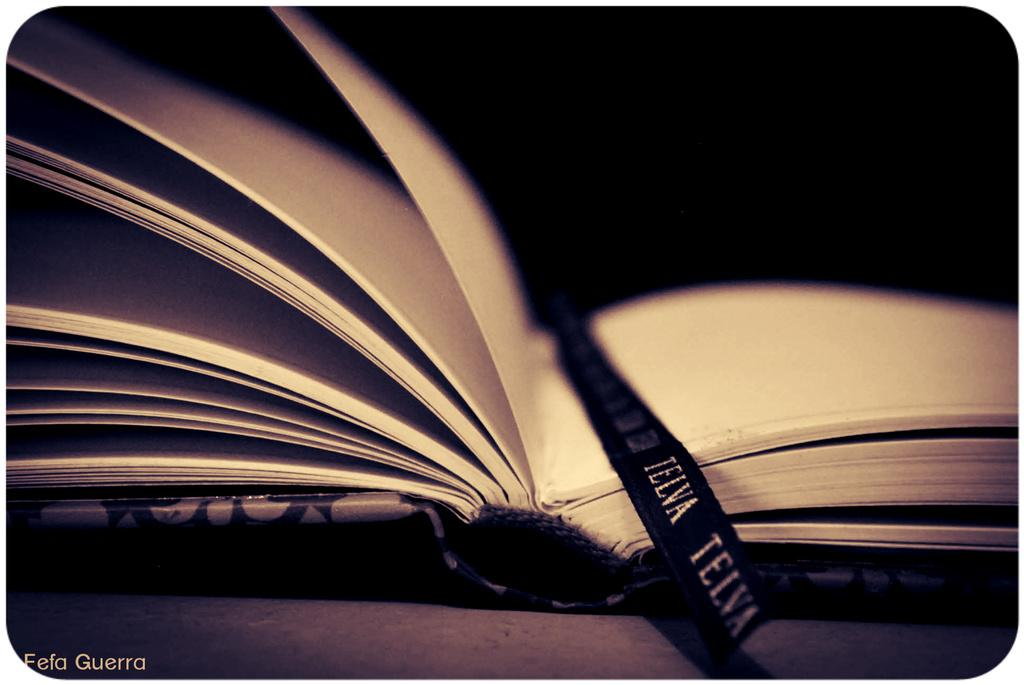What object is placed on the platform in the image? There is a book placed on a platform in the image. Can you describe the background of the image? The background of the image is dark. What type of blood can be seen dripping from the feather in the image? There is no blood or feather present in the image; it only features a book placed on a platform with a dark background. 